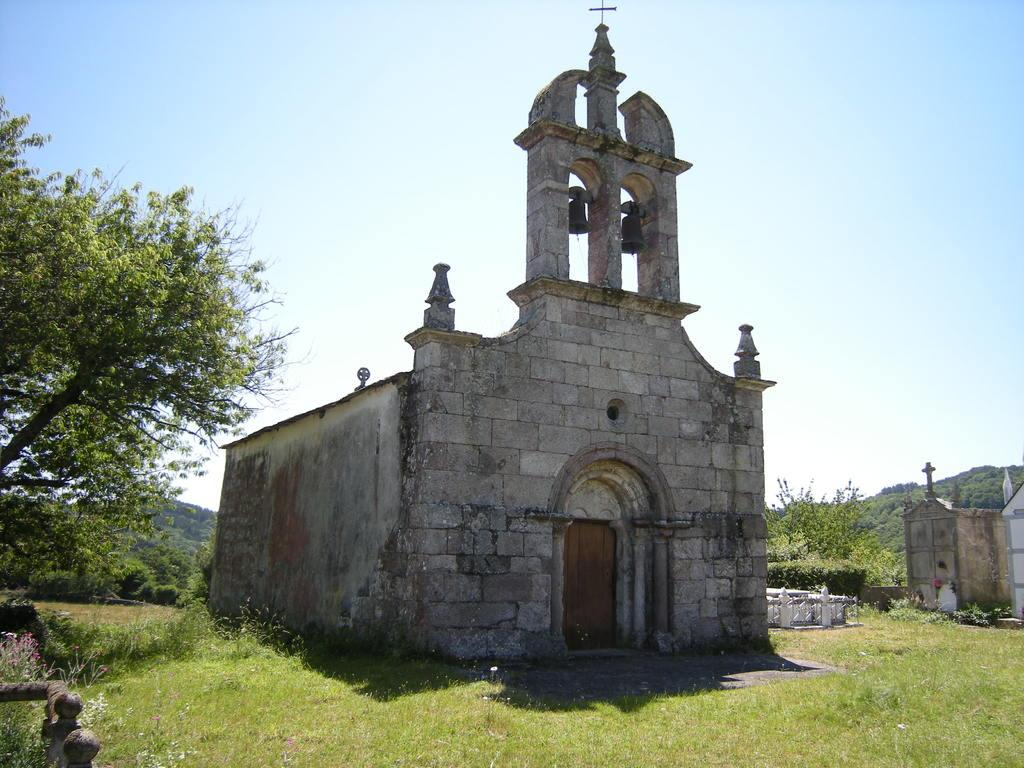What type of structure is in the image? There is a building in the image. What colors are used for the building? The building is in gray and white color. What can be seen in the background of the image? There are trees and the sky visible in the background of the image. What color are the trees? The trees are in green color. What colors are used for the sky? The sky is in white and blue color. What type of hook can be seen hanging from the building in the image? There is no hook present in the image; it only features a building, trees, and the sky. 